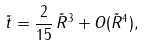Convert formula to latex. <formula><loc_0><loc_0><loc_500><loc_500>\tilde { t } = \frac { 2 } { 1 5 } \, \tilde { R } ^ { 3 } + O ( \tilde { R } ^ { 4 } ) ,</formula> 